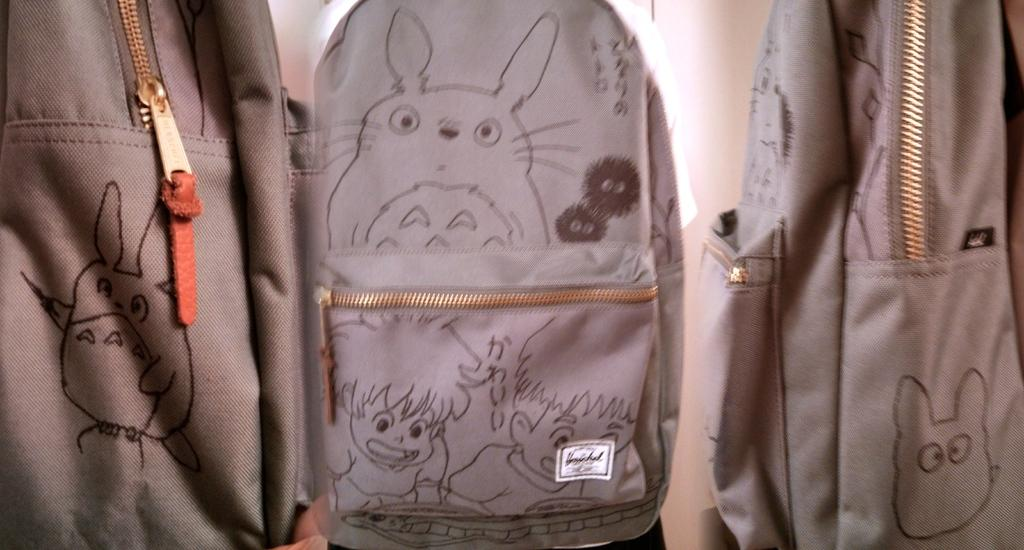What type of bag is shown in the image? There is a bag with a zip in the image. What is featured on the bag? There are crafts on the bag. Are there any other bags in the image? Yes, there is another bag beside the first bag. Can you see any kittens wearing a veil in the image? There are no kittens or veils present in the image. What type of basin is used to hold the crafts on the bag? The image does not show a basin; it only features a bag with crafts on it. 